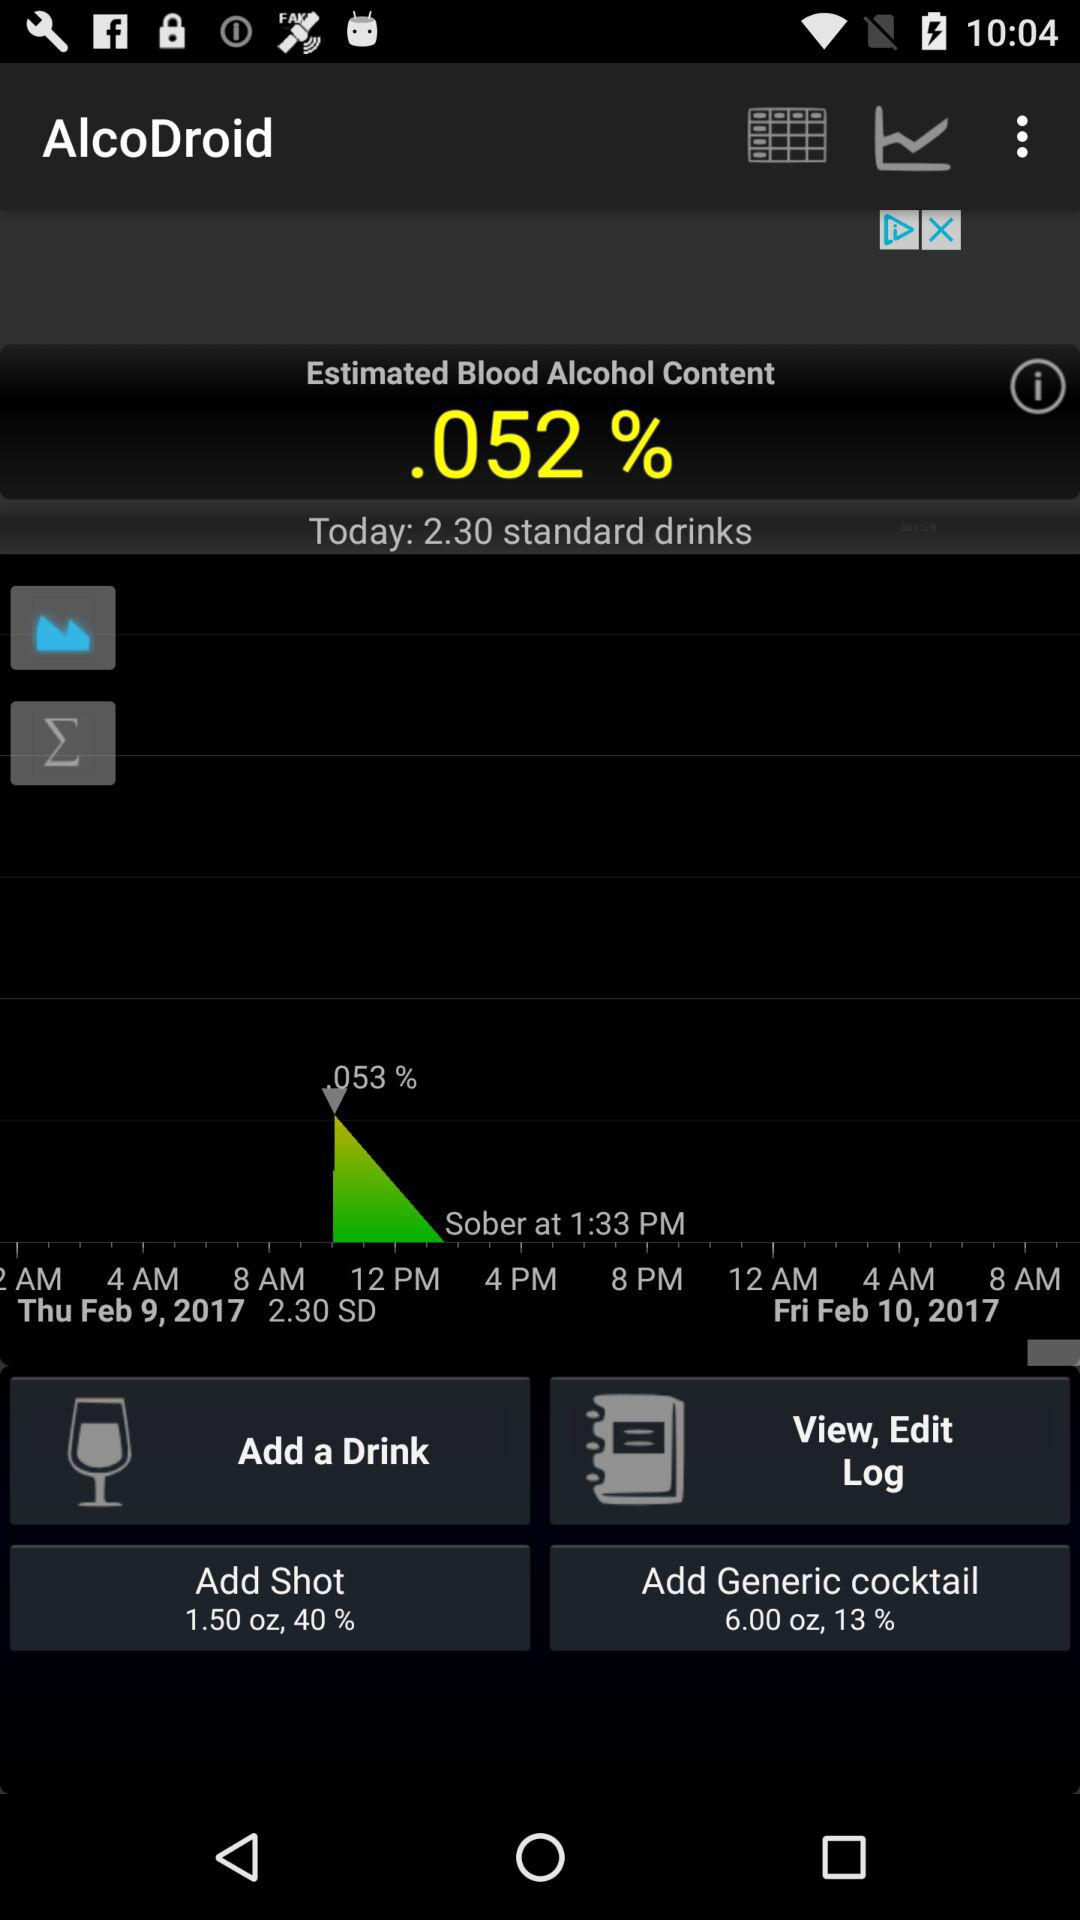What is the data in "Generic cocktail"? The data in "Generic cocktail" is 6 oz and 13%. 